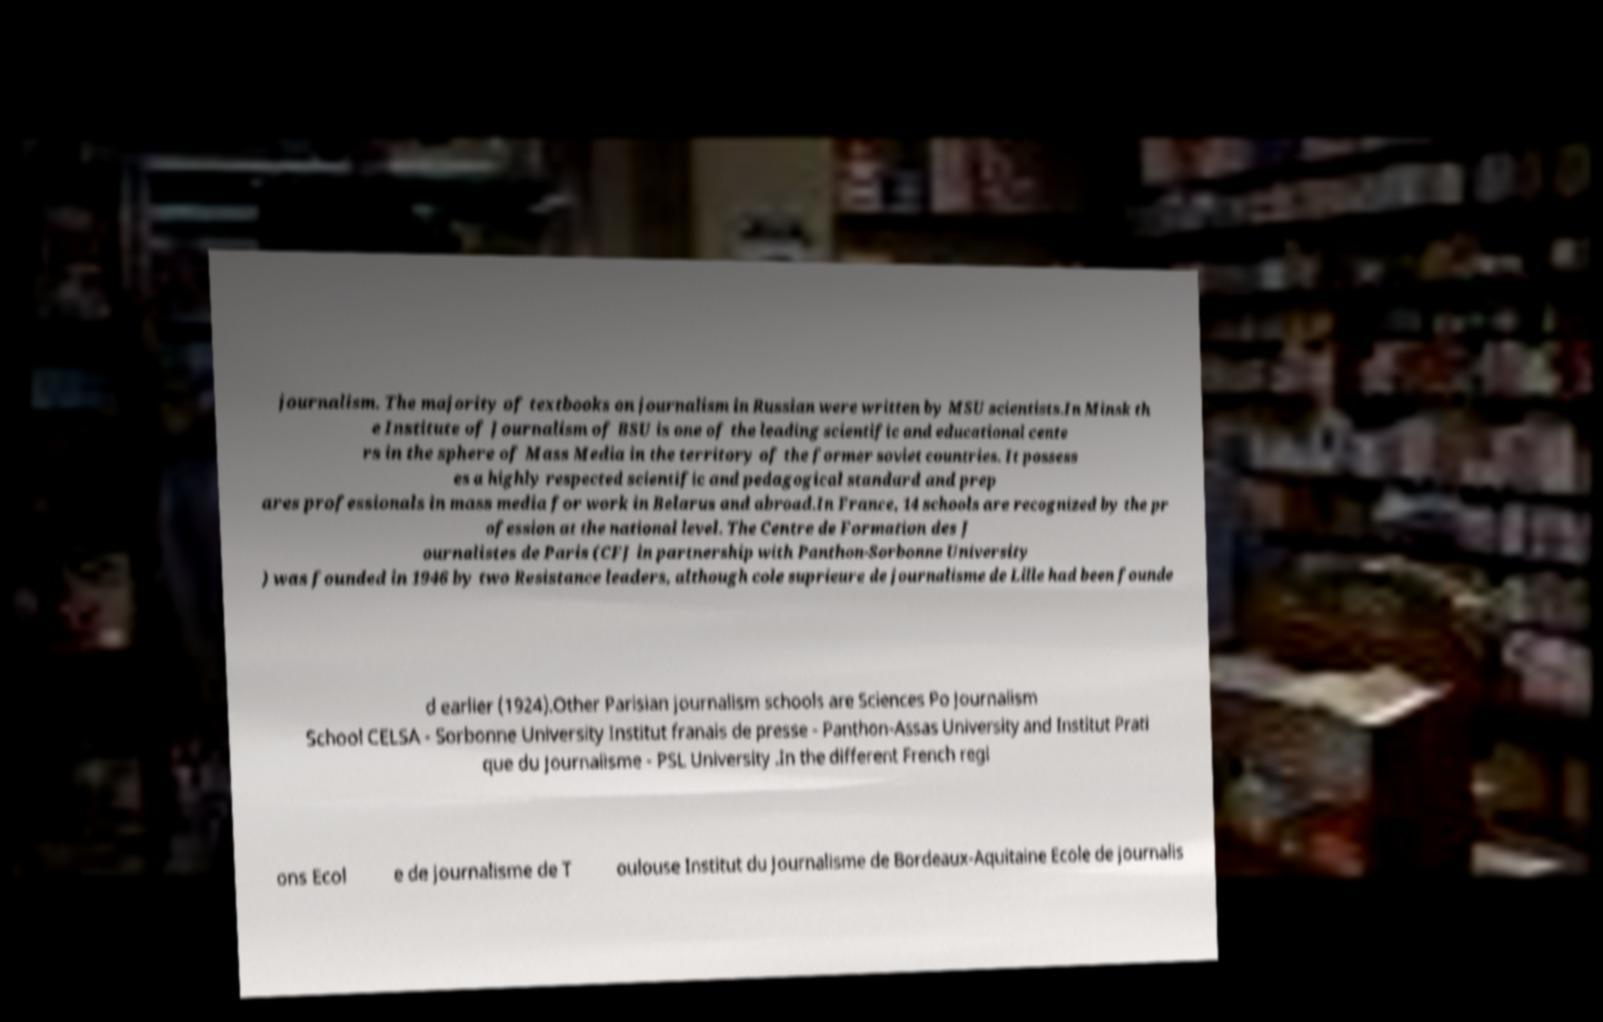Please identify and transcribe the text found in this image. journalism. The majority of textbooks on journalism in Russian were written by MSU scientists.In Minsk th e Institute of Journalism of BSU is one of the leading scientific and educational cente rs in the sphere of Mass Media in the territory of the former soviet countries. It possess es a highly respected scientific and pedagogical standard and prep ares professionals in mass media for work in Belarus and abroad.In France, 14 schools are recognized by the pr ofession at the national level. The Centre de Formation des J ournalistes de Paris (CFJ in partnership with Panthon-Sorbonne University ) was founded in 1946 by two Resistance leaders, although cole suprieure de journalisme de Lille had been founde d earlier (1924).Other Parisian journalism schools are Sciences Po Journalism School CELSA - Sorbonne University Institut franais de presse - Panthon-Assas University and Institut Prati que du Journalisme - PSL University .In the different French regi ons Ecol e de journalisme de T oulouse Institut du Journalisme de Bordeaux-Aquitaine Ecole de journalis 